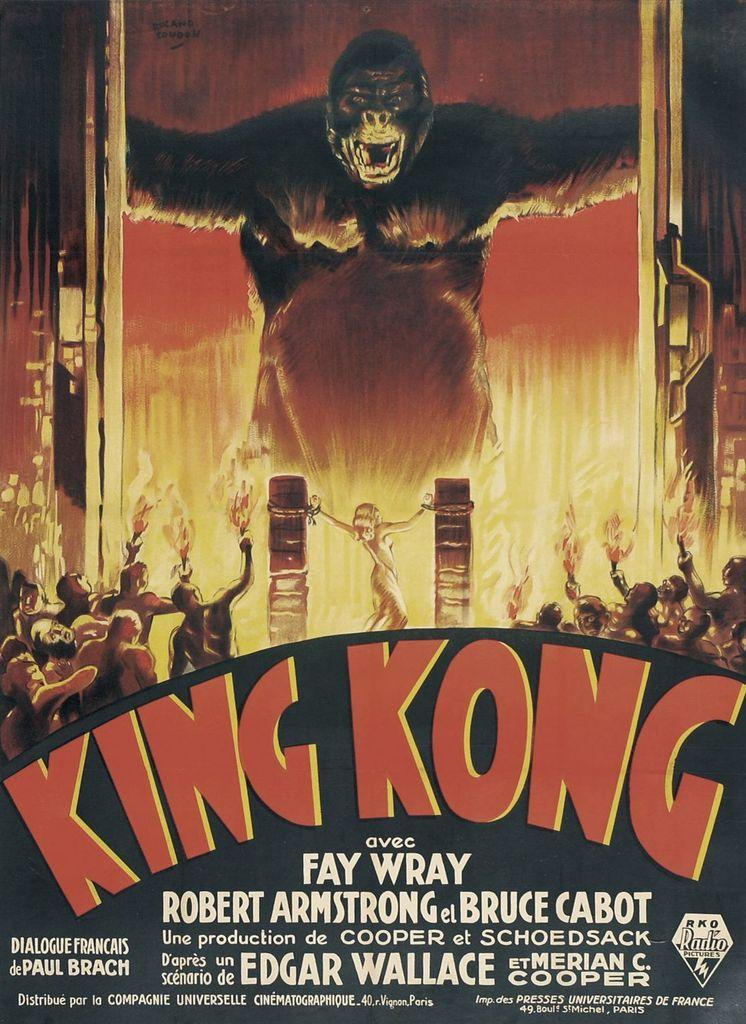Provide a one-sentence caption for the provided image. King Kong movie advertisement directed by Fay Wray. 